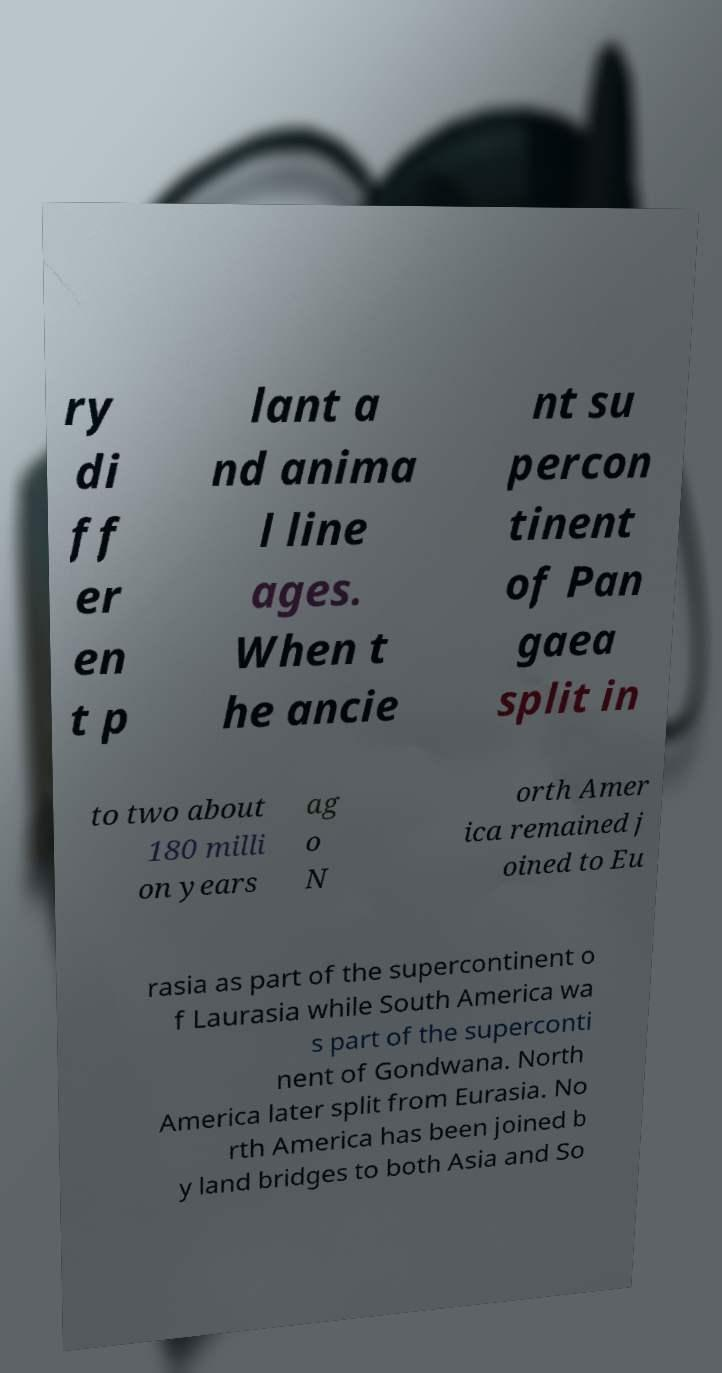Please identify and transcribe the text found in this image. ry di ff er en t p lant a nd anima l line ages. When t he ancie nt su percon tinent of Pan gaea split in to two about 180 milli on years ag o N orth Amer ica remained j oined to Eu rasia as part of the supercontinent o f Laurasia while South America wa s part of the superconti nent of Gondwana. North America later split from Eurasia. No rth America has been joined b y land bridges to both Asia and So 